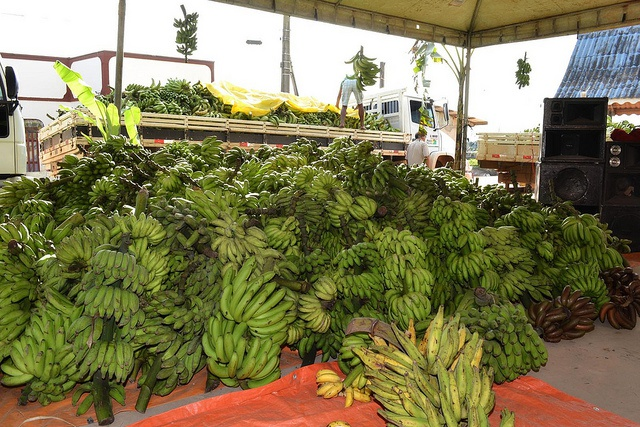Describe the objects in this image and their specific colors. I can see banana in white, darkgreen, black, and olive tones, truck in white, tan, ivory, and black tones, banana in white, darkgreen, olive, and black tones, banana in white, darkgreen, and olive tones, and banana in white, olive, and black tones in this image. 